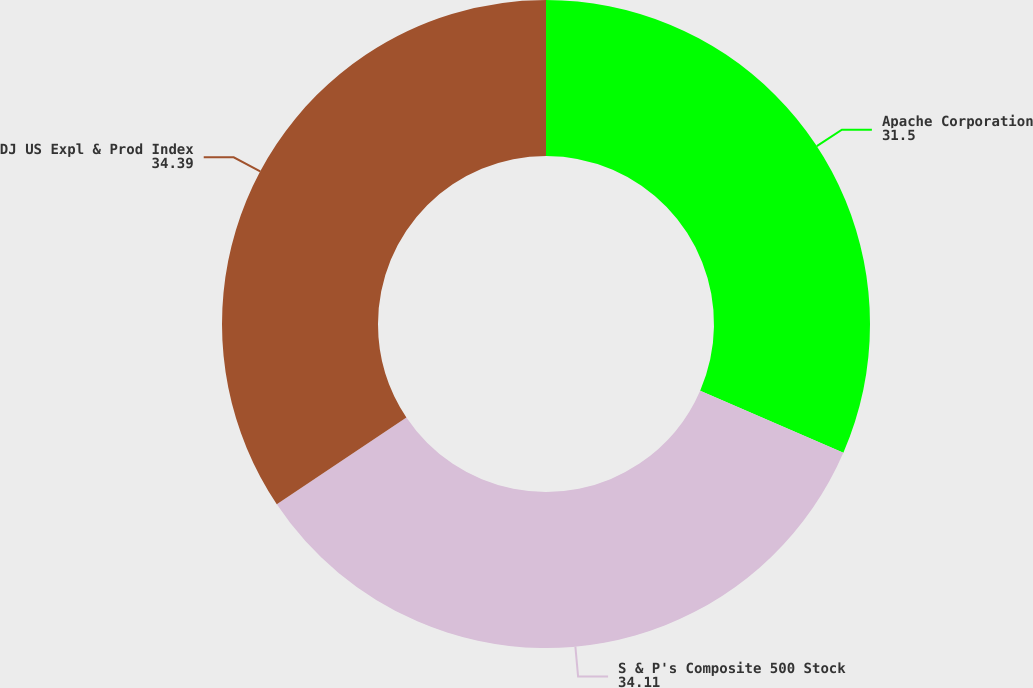Convert chart. <chart><loc_0><loc_0><loc_500><loc_500><pie_chart><fcel>Apache Corporation<fcel>S & P's Composite 500 Stock<fcel>DJ US Expl & Prod Index<nl><fcel>31.5%<fcel>34.11%<fcel>34.39%<nl></chart> 